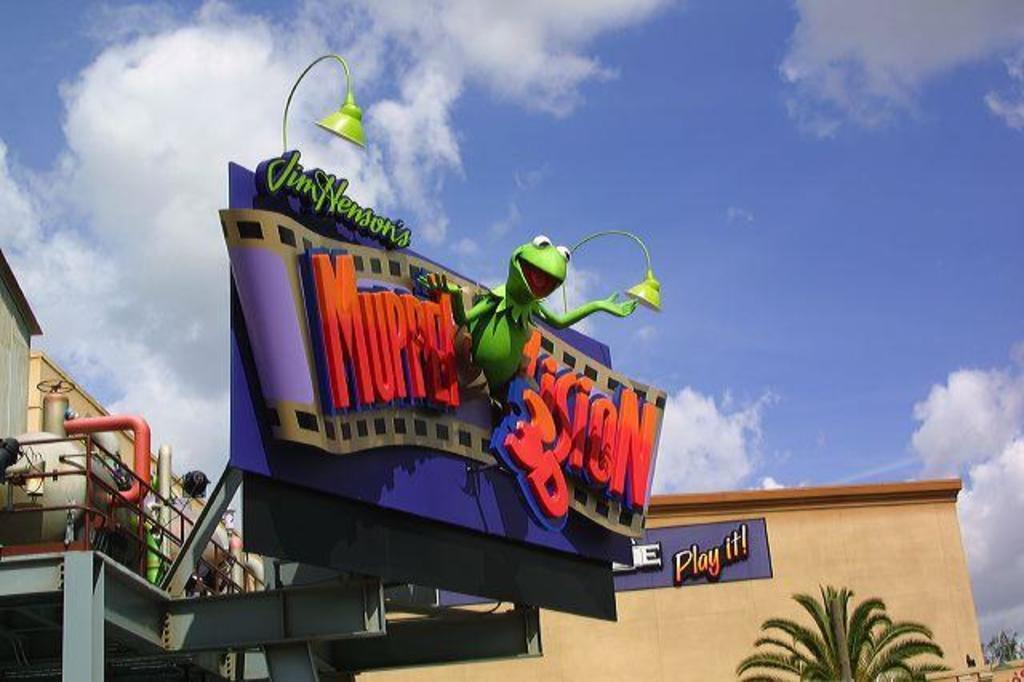Can you describe this image briefly? This image consists of a hoarding. On the left, there is a tank. On the right, there is a tree. In the background, there is a building. At the top, there are clouds in the sky. In the front, there is a name board. 